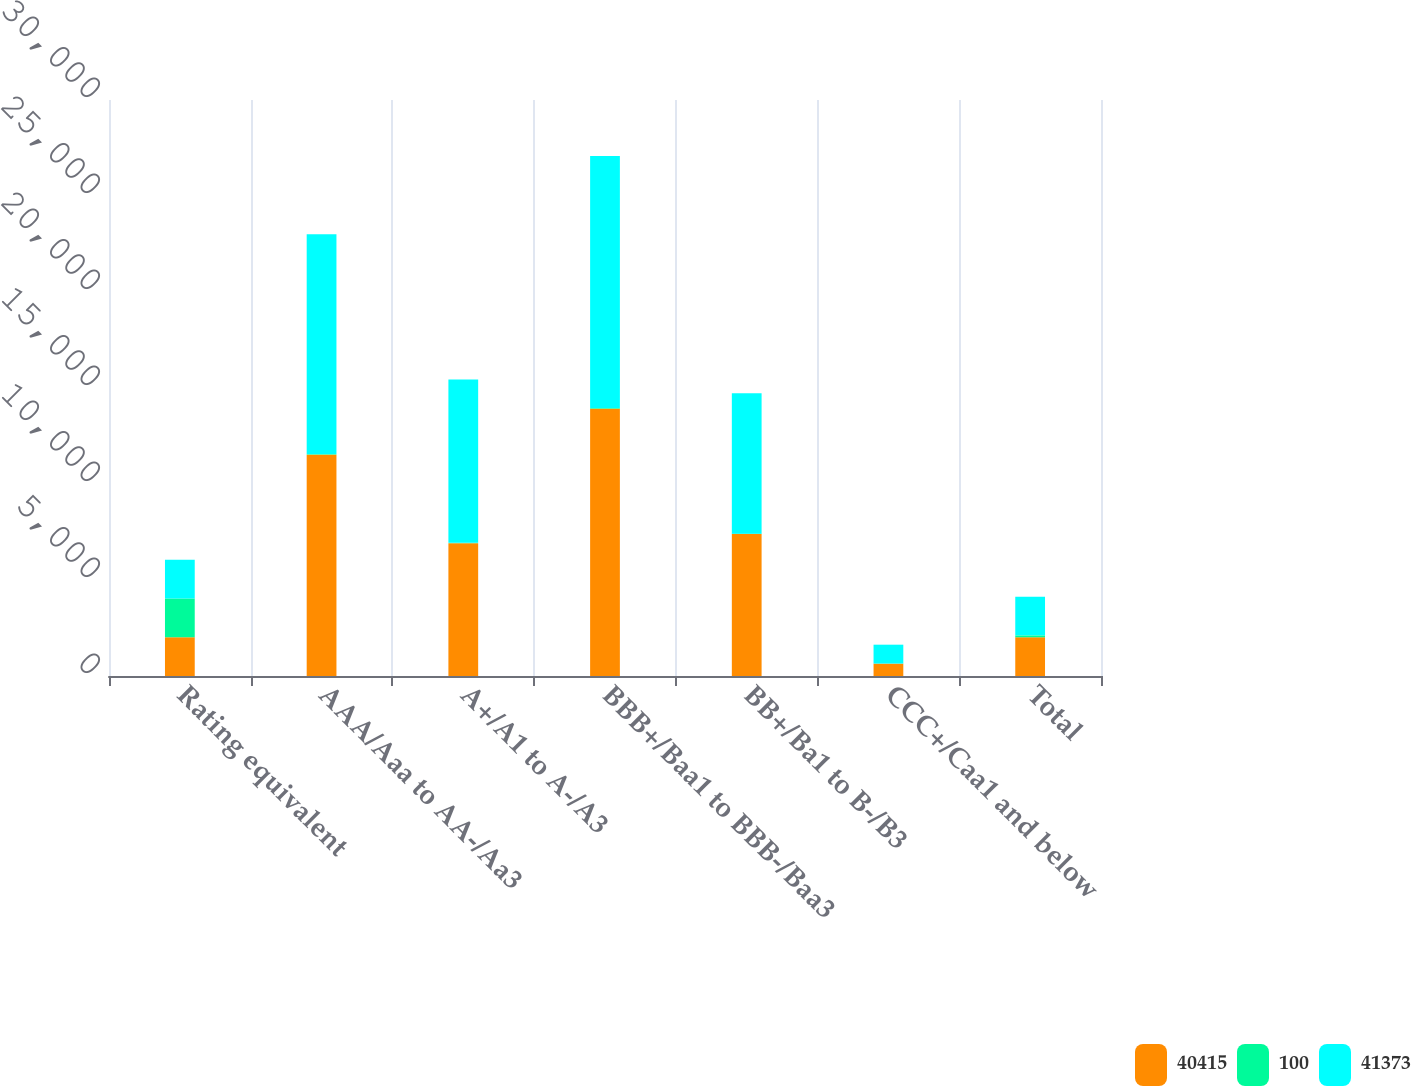Convert chart. <chart><loc_0><loc_0><loc_500><loc_500><stacked_bar_chart><ecel><fcel>Rating equivalent<fcel>AAA/Aaa to AA-/Aa3<fcel>A+/A1 to A-/A3<fcel>BBB+/Baa1 to BBB-/Baa3<fcel>BB+/Ba1 to B-/B3<fcel>CCC+/Caa1 and below<fcel>Total<nl><fcel>40415<fcel>2017<fcel>11529<fcel>6919<fcel>13925<fcel>7397<fcel>645<fcel>2017<nl><fcel>100<fcel>2017<fcel>29<fcel>17<fcel>34<fcel>18<fcel>2<fcel>100<nl><fcel>41373<fcel>2016<fcel>11449<fcel>8505<fcel>13127<fcel>7308<fcel>984<fcel>2017<nl></chart> 